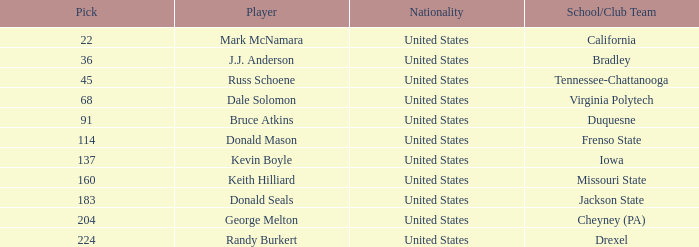What is the country of origin for the drexel player who had a choice above 183? United States. 